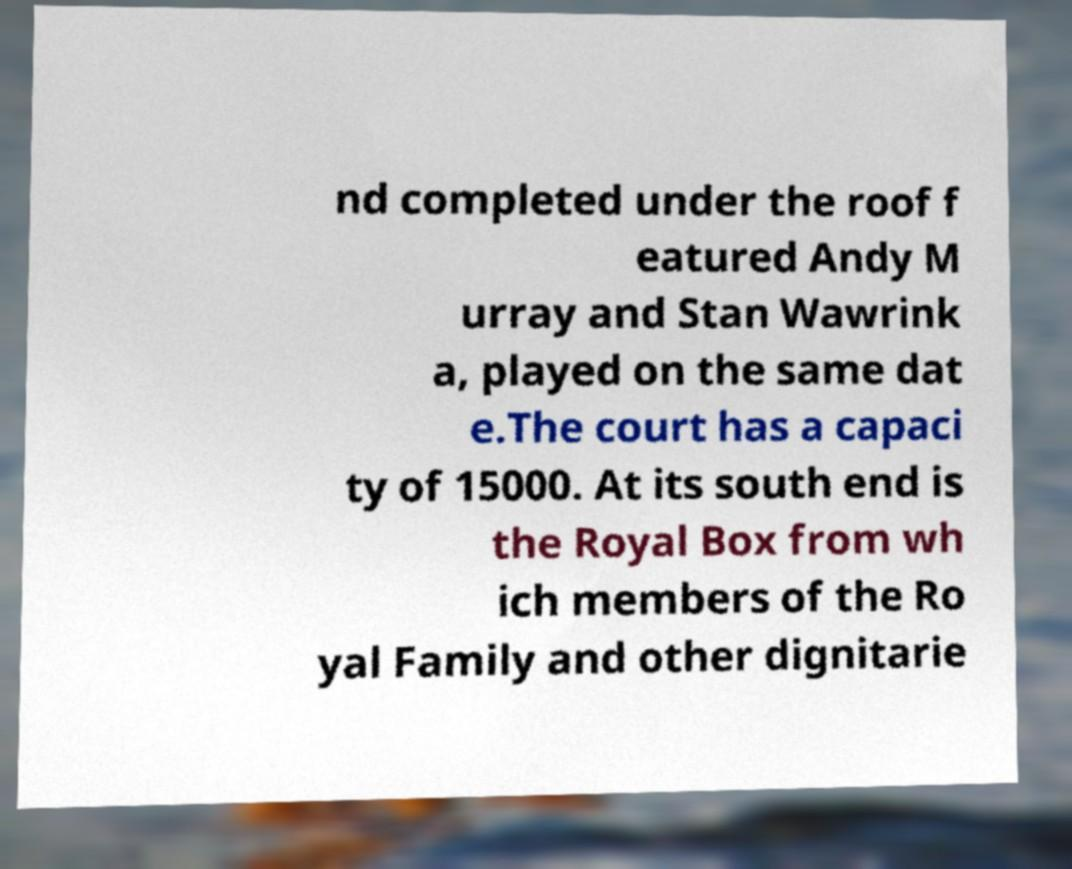Could you extract and type out the text from this image? nd completed under the roof f eatured Andy M urray and Stan Wawrink a, played on the same dat e.The court has a capaci ty of 15000. At its south end is the Royal Box from wh ich members of the Ro yal Family and other dignitarie 